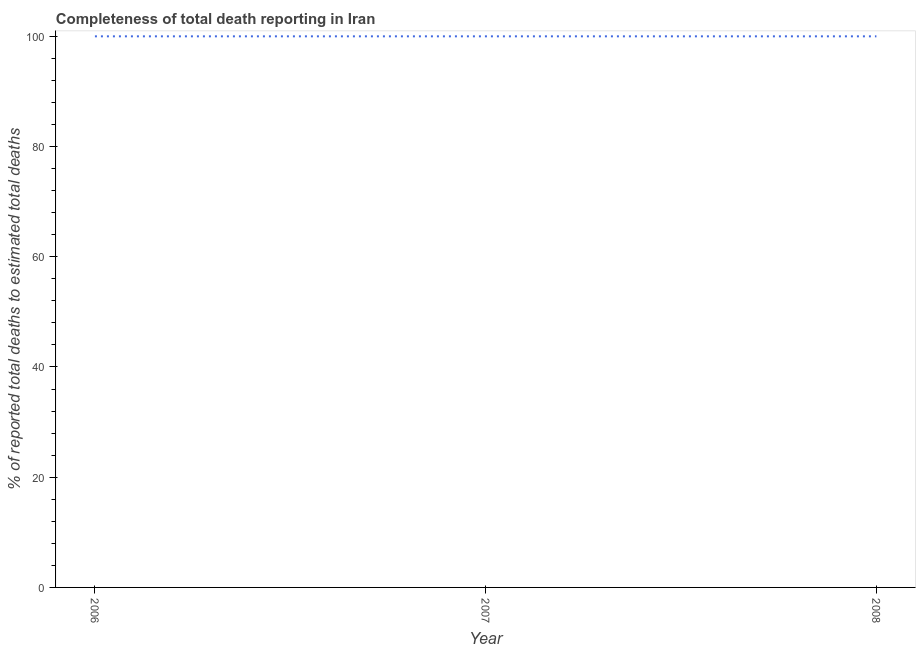What is the completeness of total death reports in 2006?
Your answer should be compact. 100. Across all years, what is the maximum completeness of total death reports?
Offer a very short reply. 100. Across all years, what is the minimum completeness of total death reports?
Your response must be concise. 100. What is the sum of the completeness of total death reports?
Your answer should be compact. 300. What is the difference between the completeness of total death reports in 2006 and 2007?
Your response must be concise. 0. What is the average completeness of total death reports per year?
Offer a terse response. 100. What is the median completeness of total death reports?
Ensure brevity in your answer.  100. What is the difference between the highest and the lowest completeness of total death reports?
Ensure brevity in your answer.  0. In how many years, is the completeness of total death reports greater than the average completeness of total death reports taken over all years?
Your response must be concise. 0. How many lines are there?
Your answer should be very brief. 1. How many years are there in the graph?
Make the answer very short. 3. What is the difference between two consecutive major ticks on the Y-axis?
Ensure brevity in your answer.  20. Are the values on the major ticks of Y-axis written in scientific E-notation?
Offer a terse response. No. What is the title of the graph?
Make the answer very short. Completeness of total death reporting in Iran. What is the label or title of the Y-axis?
Ensure brevity in your answer.  % of reported total deaths to estimated total deaths. What is the % of reported total deaths to estimated total deaths in 2007?
Keep it short and to the point. 100. What is the difference between the % of reported total deaths to estimated total deaths in 2006 and 2008?
Your answer should be very brief. 0. What is the difference between the % of reported total deaths to estimated total deaths in 2007 and 2008?
Your response must be concise. 0. What is the ratio of the % of reported total deaths to estimated total deaths in 2006 to that in 2007?
Offer a very short reply. 1. 